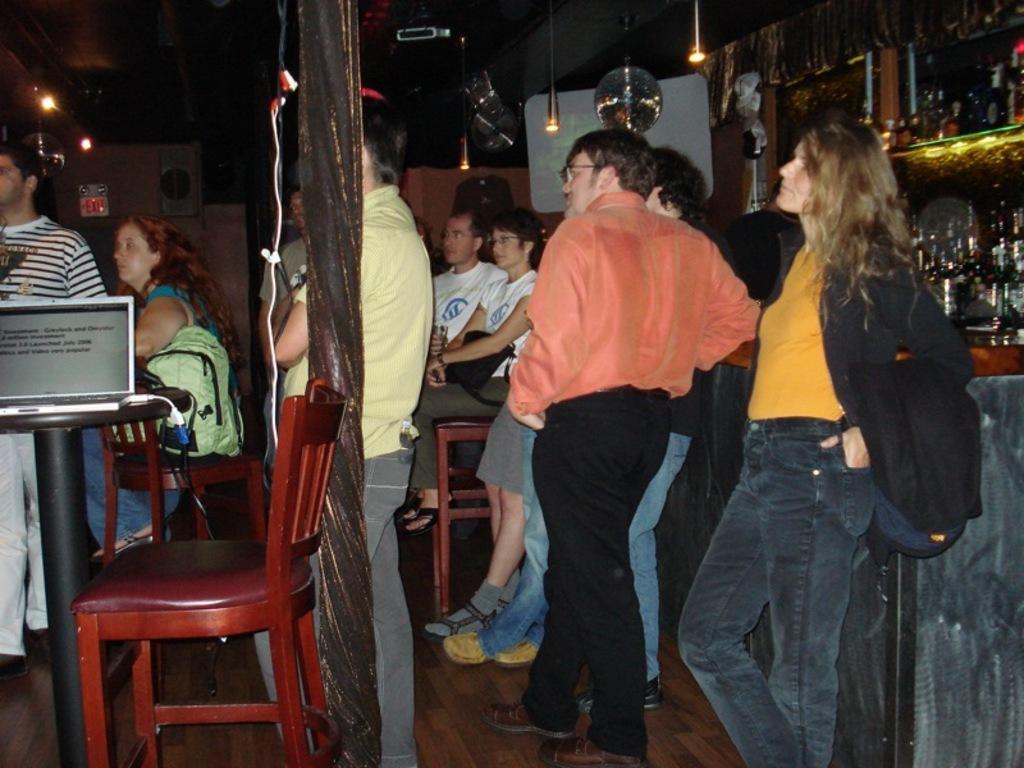Describe this image in one or two sentences. In this picture we can see a group of people where some are sitting on chairs and some are standing carrying their bags and on table we can see laptop and in background we can see lights, racks glass items on it. 